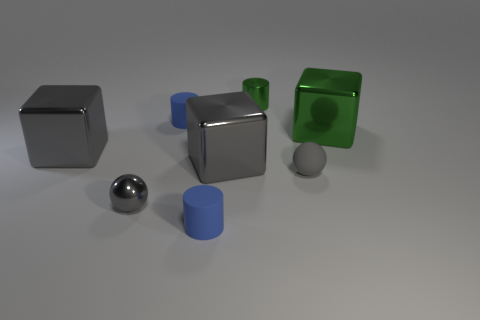The small cylinder that is left of the blue matte object in front of the large green shiny block is what color?
Offer a terse response. Blue. What is the color of the metal object that is the same shape as the tiny gray rubber thing?
Make the answer very short. Gray. Is there any other thing that has the same material as the green cylinder?
Your answer should be very brief. Yes. There is a metallic thing that is the same shape as the gray rubber thing; what size is it?
Give a very brief answer. Small. What material is the gray block on the left side of the gray metallic ball?
Make the answer very short. Metal. Is the number of cylinders that are on the left side of the tiny green cylinder less than the number of tiny purple metallic cubes?
Provide a succinct answer. No. There is a small thing in front of the tiny metal ball to the left of the small rubber ball; what is its shape?
Provide a succinct answer. Cylinder. What color is the matte sphere?
Offer a very short reply. Gray. How many other things are the same size as the matte ball?
Ensure brevity in your answer.  4. There is a large block that is right of the tiny metal ball and in front of the large green cube; what material is it?
Keep it short and to the point. Metal. 